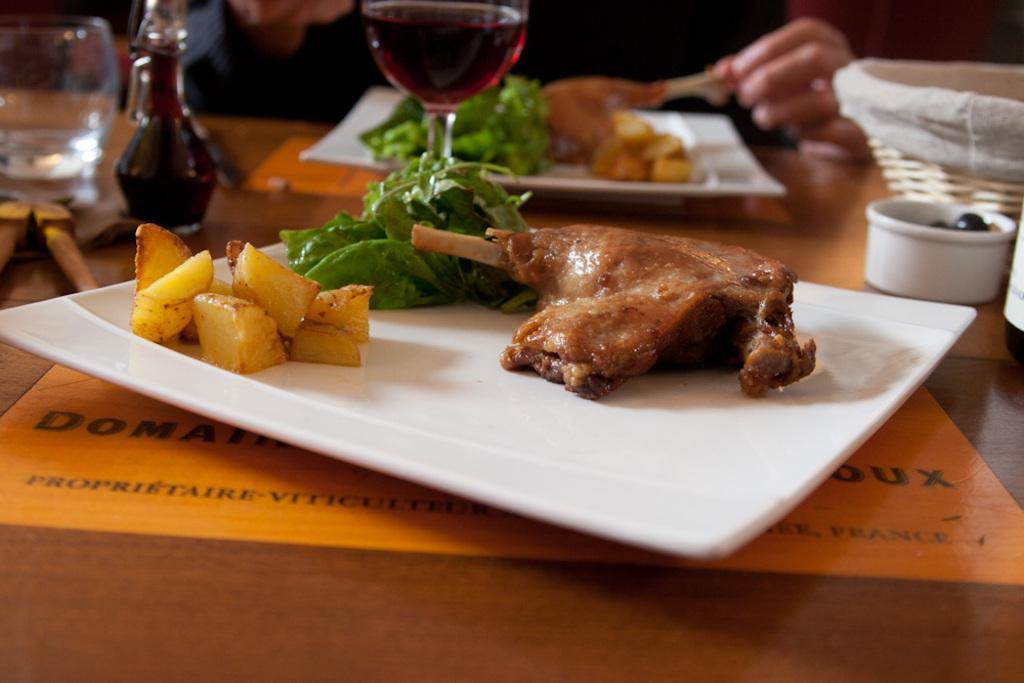Describe this image in one or two sentences. In this image there is a table and we can see glasses, basket, bowl, plates containing meat, leafy vegetable and potatoes placed on the table. In the background we can see a person sitting and holding meat. 